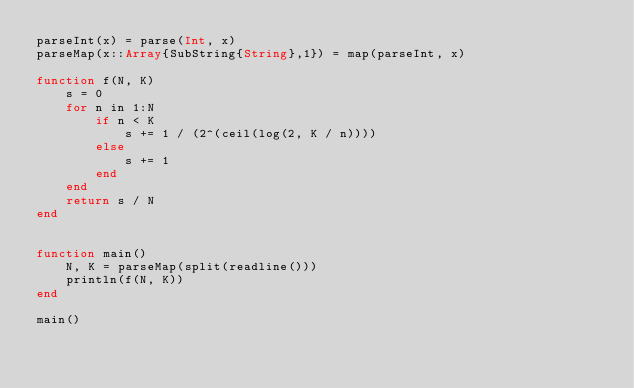Convert code to text. <code><loc_0><loc_0><loc_500><loc_500><_Julia_>parseInt(x) = parse(Int, x)
parseMap(x::Array{SubString{String},1}) = map(parseInt, x)

function f(N, K)
    s = 0
    for n in 1:N
        if n < K
            s += 1 / (2^(ceil(log(2, K / n)))) 
        else
            s += 1
        end
    end
    return s / N 
end


function main()
    N, K = parseMap(split(readline()))
    println(f(N, K))
end

main()</code> 